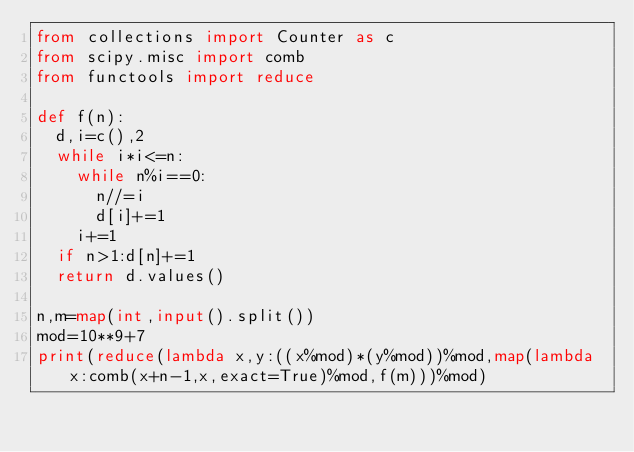<code> <loc_0><loc_0><loc_500><loc_500><_Python_>from collections import Counter as c
from scipy.misc import comb
from functools import reduce

def f(n):
  d,i=c(),2
  while i*i<=n:
    while n%i==0:
      n//=i
      d[i]+=1
    i+=1
  if n>1:d[n]+=1
  return d.values()

n,m=map(int,input().split())
mod=10**9+7
print(reduce(lambda x,y:((x%mod)*(y%mod))%mod,map(lambda x:comb(x+n-1,x,exact=True)%mod,f(m)))%mod)</code> 